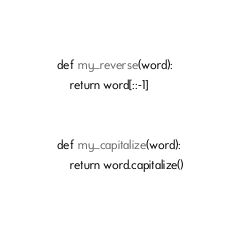Convert code to text. <code><loc_0><loc_0><loc_500><loc_500><_Python_>def my_reverse(word):
    return word[::-1]


def my_capitalize(word):
    return word.capitalize()
</code> 